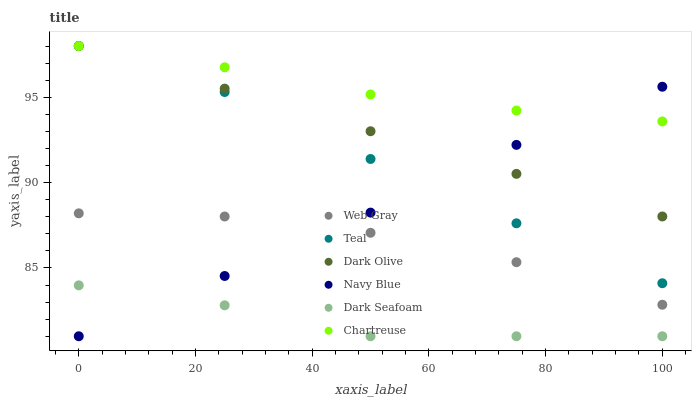Does Dark Seafoam have the minimum area under the curve?
Answer yes or no. Yes. Does Chartreuse have the maximum area under the curve?
Answer yes or no. Yes. Does Navy Blue have the minimum area under the curve?
Answer yes or no. No. Does Navy Blue have the maximum area under the curve?
Answer yes or no. No. Is Dark Olive the smoothest?
Answer yes or no. Yes. Is Dark Seafoam the roughest?
Answer yes or no. Yes. Is Navy Blue the smoothest?
Answer yes or no. No. Is Navy Blue the roughest?
Answer yes or no. No. Does Navy Blue have the lowest value?
Answer yes or no. Yes. Does Dark Olive have the lowest value?
Answer yes or no. No. Does Teal have the highest value?
Answer yes or no. Yes. Does Navy Blue have the highest value?
Answer yes or no. No. Is Dark Seafoam less than Teal?
Answer yes or no. Yes. Is Teal greater than Web Gray?
Answer yes or no. Yes. Does Dark Olive intersect Chartreuse?
Answer yes or no. Yes. Is Dark Olive less than Chartreuse?
Answer yes or no. No. Is Dark Olive greater than Chartreuse?
Answer yes or no. No. Does Dark Seafoam intersect Teal?
Answer yes or no. No. 